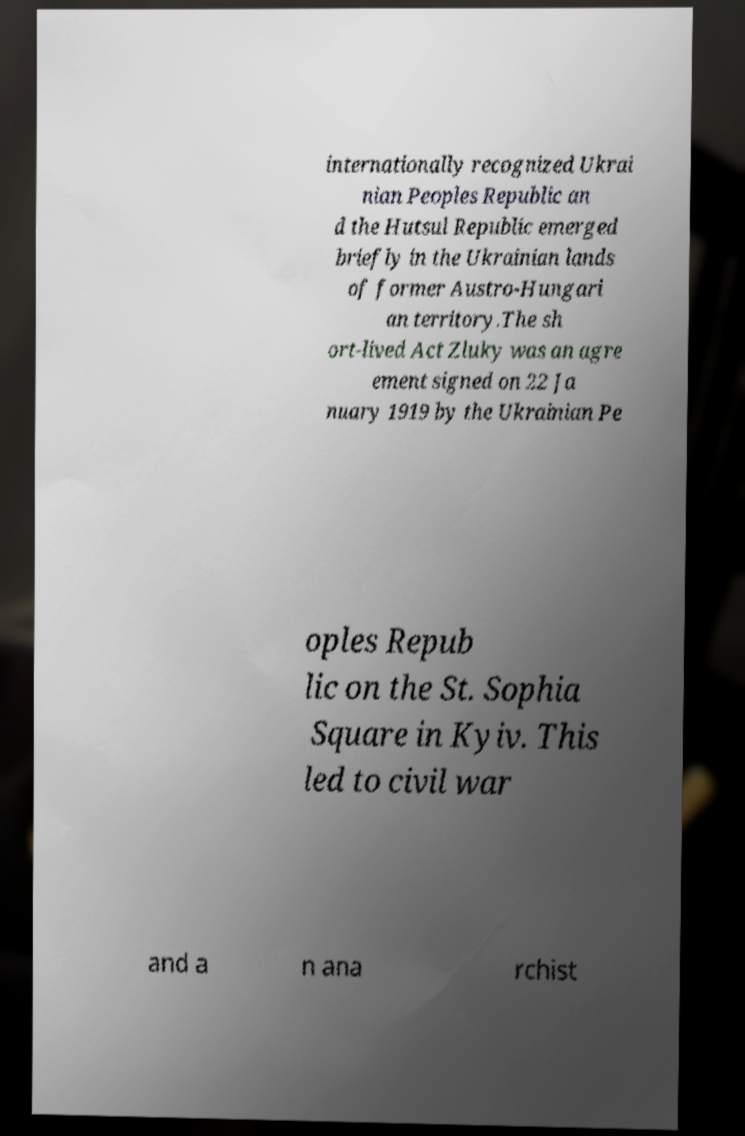There's text embedded in this image that I need extracted. Can you transcribe it verbatim? internationally recognized Ukrai nian Peoples Republic an d the Hutsul Republic emerged briefly in the Ukrainian lands of former Austro-Hungari an territory.The sh ort-lived Act Zluky was an agre ement signed on 22 Ja nuary 1919 by the Ukrainian Pe oples Repub lic on the St. Sophia Square in Kyiv. This led to civil war and a n ana rchist 